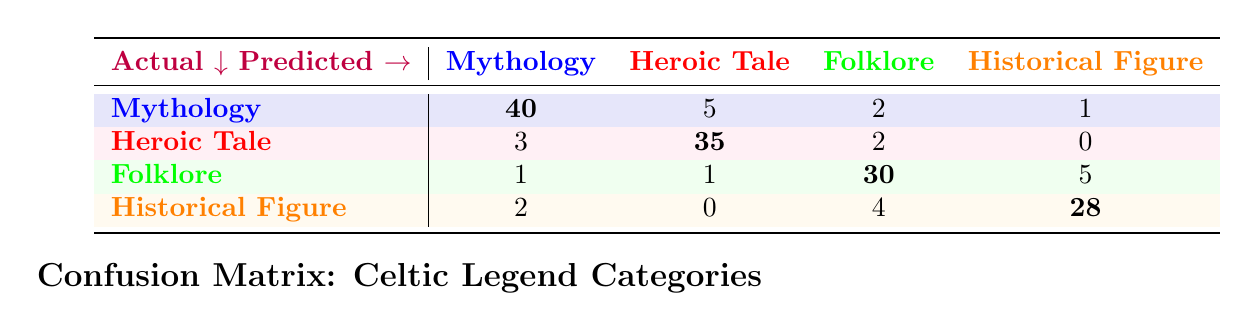What is the predicted value for "Folklore" classified as "Folklore"? The predicted value for "Folklore" classified as "Folklore" is found in the third row and third column of the table, which shows a value of 30.
Answer: 30 How many total predictions were made for "Mythology"? To find the total predictions for "Mythology," I add up all the values in the "Mythology" row: 40 + 5 + 2 + 1 = 48.
Answer: 48 Is "Heroic Tale" accurately predicted more times than "Historical Figure"? Looking at the diagonal values, "Heroic Tale" has a predicted value of 35 and "Historical Figure" has a predicted value of 28. Since 35 is greater than 28, it is true.
Answer: Yes What is the total number of incorrectly predicted "Historical Figure" samples? The incorrectly predicted samples for "Historical Figure" are the off-diagonal values in the "Historical Figure" row: 2 (predicted as Mythology) + 0 (predicted as Heroic Tale) + 4 (predicted as Folklore) = 6.
Answer: 6 What percentage of actual "Mythology" were correctly predicted? From the "Mythology" row, the correctly predicted value is 40. To find the total actual instances, I sum all values in that row: 40 + 5 + 2 + 1 = 48. The percentage of correctly predicted instances is (40/48) * 100 = 83.33%.
Answer: 83.33% How many total instances were predicted as "Folklore"? The predicted instances as "Folklore" can be found by summing the entire "Folklore" column: 2 (Mythology) + 2 (Heroic Tale) + 30 (Folklore) + 4 (Historical Figure) = 38.
Answer: 38 Out of all predictions, which category has the highest total predicted values? To find the category with the highest total predicted values, I will sum the values in each row: Mythology (48), Heroic Tale (40), Folklore (38), Historical Figure (34). Mythology has the highest total with 48.
Answer: Mythology What is the total count of samples classified as "Heroic Tale" that were incorrectly predicted? The incorrectly predicted samples for "Heroic Tale" can be found in the off-diagonal values of its row: 3 (predicted as Mythology) + 2 (predicted as Folklore) = 5.
Answer: 5 What is the average number of predictions made across all categories? To find the average, I will sum all numbers in the matrix: 40 + 5 + 2 + 1 + 3 + 35 + 2 + 0 + 1 + 1 + 30 + 5 + 2 + 0 + 4 + 28 =  118. There are 16 predictions in total, so the average is 118/16 = 7.375.
Answer: 7.375 